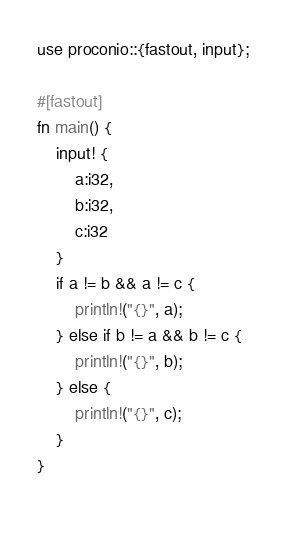<code> <loc_0><loc_0><loc_500><loc_500><_Rust_>use proconio::{fastout, input};

#[fastout]
fn main() {
    input! {
        a:i32,
        b:i32,
        c:i32
    }
    if a != b && a != c {
        println!("{}", a);
    } else if b != a && b != c {
        println!("{}", b);
    } else {
        println!("{}", c);
    }
}
 </code> 